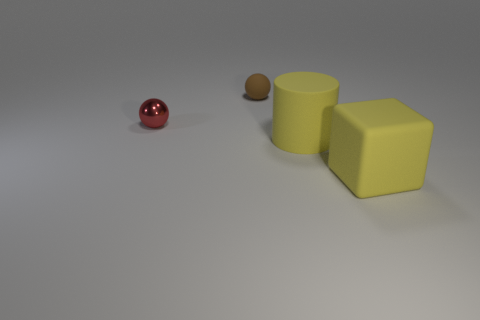Are there any big rubber things that have the same color as the rubber cube?
Provide a short and direct response. Yes. Do the matte cylinder and the matte thing in front of the large yellow matte cylinder have the same color?
Offer a terse response. Yes. What is the material of the big cylinder that is the same color as the large rubber block?
Ensure brevity in your answer.  Rubber. There is a yellow thing that is on the left side of the yellow thing right of the big cylinder; what size is it?
Ensure brevity in your answer.  Large. What number of big things are purple matte things or metallic objects?
Your answer should be compact. 0. Is the number of large rubber things less than the number of red metal balls?
Offer a terse response. No. Is the color of the metal thing the same as the big cylinder?
Provide a succinct answer. No. Are there more big yellow cubes than tiny cyan blocks?
Provide a short and direct response. Yes. What number of other things are there of the same color as the tiny rubber sphere?
Provide a short and direct response. 0. What number of tiny brown matte objects are behind the small object to the left of the brown matte ball?
Make the answer very short. 1. 